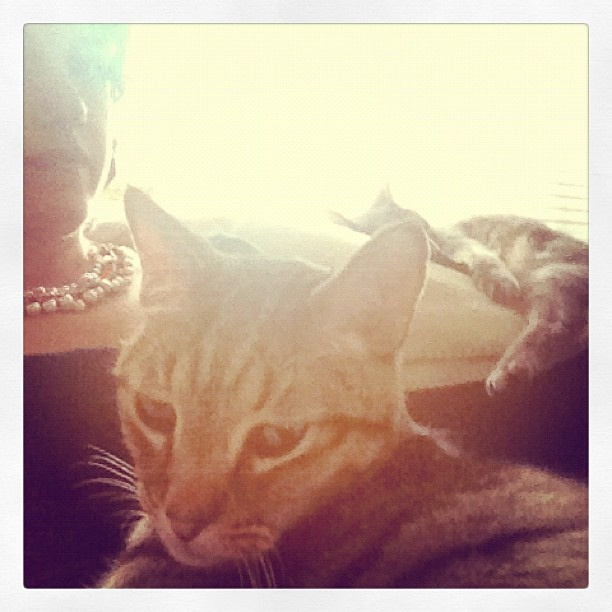Describe the objects in this image and their specific colors. I can see cat in white, brown, tan, and purple tones and people in white, brown, purple, and tan tones in this image. 